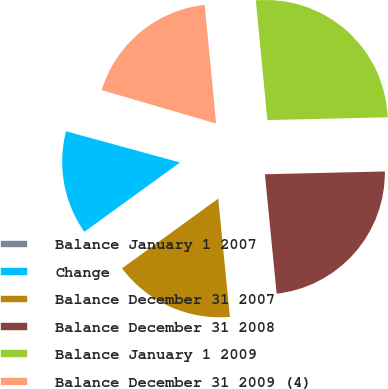Convert chart to OTSL. <chart><loc_0><loc_0><loc_500><loc_500><pie_chart><fcel>Balance January 1 2007<fcel>Change<fcel>Balance December 31 2007<fcel>Balance December 31 2008<fcel>Balance January 1 2009<fcel>Balance December 31 2009 (4)<nl><fcel>0.28%<fcel>14.23%<fcel>16.58%<fcel>23.81%<fcel>26.16%<fcel>18.94%<nl></chart> 